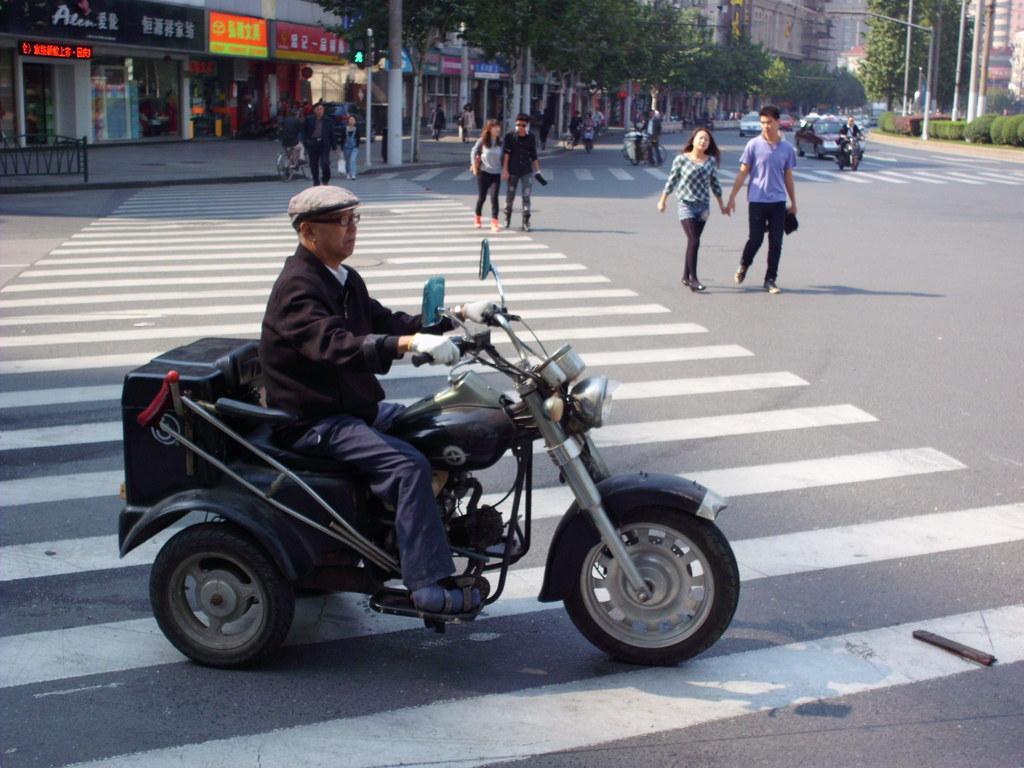Describe this image in one or two sentences. Few persons are walking and few persons are sitting on the bike. We can see vehicles on the road. On the background we can see buildings,trees,pole. This person wear cap,glasses. 